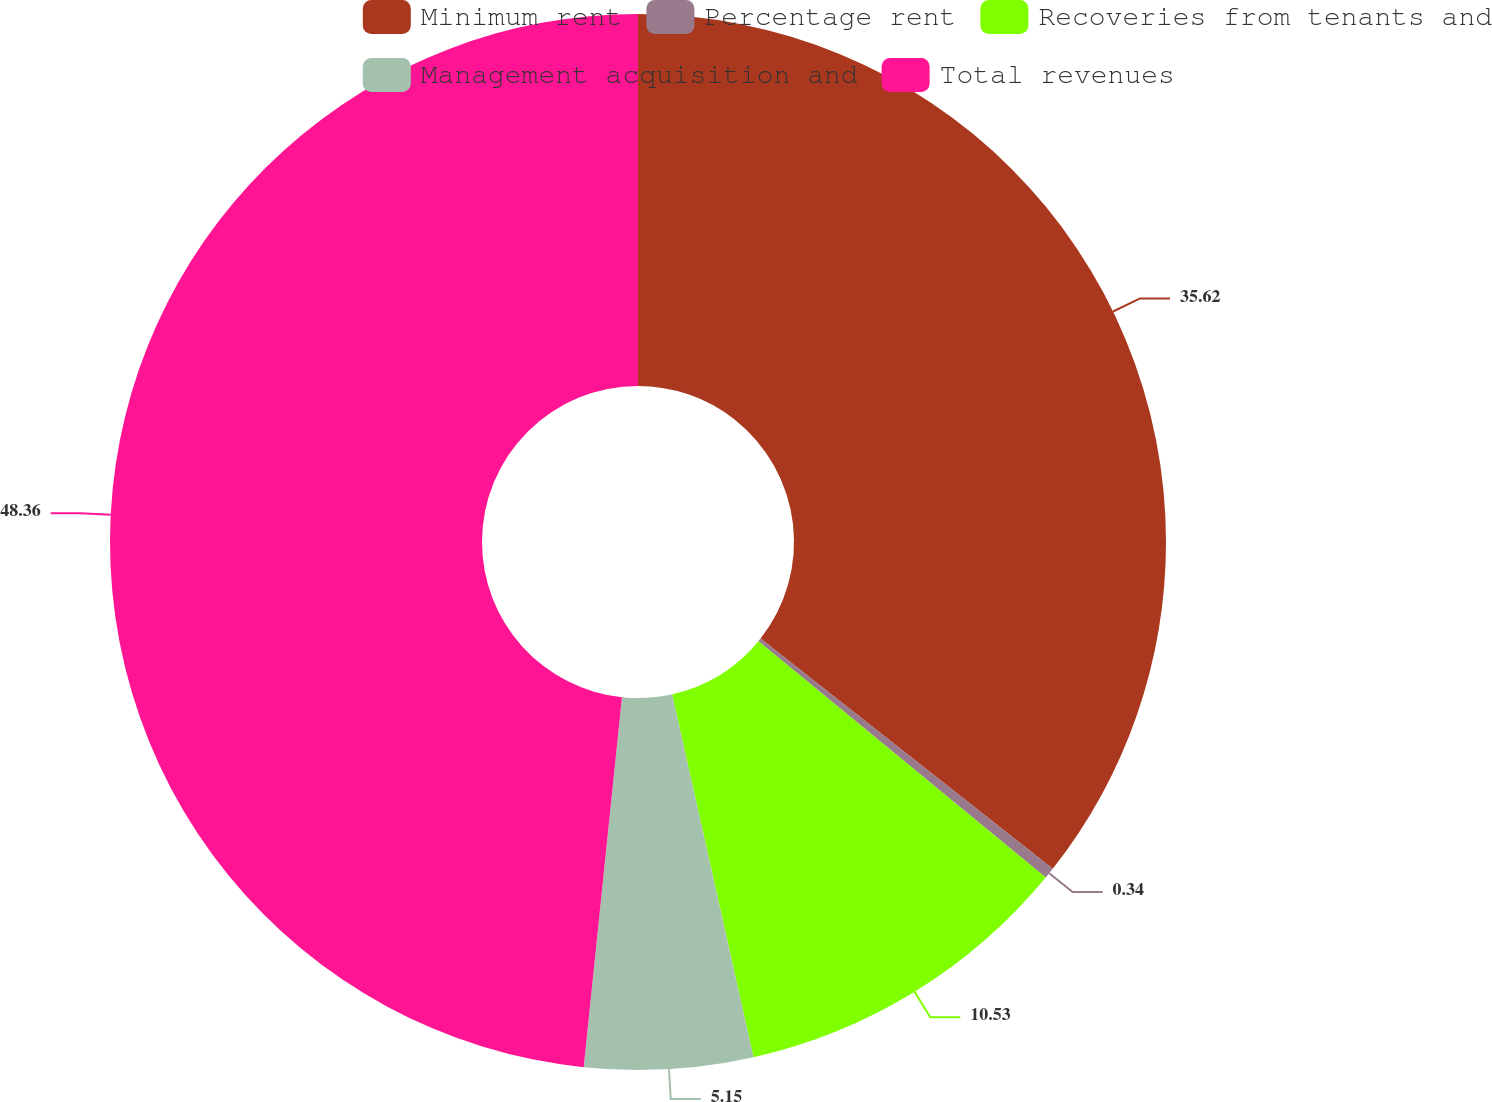Convert chart to OTSL. <chart><loc_0><loc_0><loc_500><loc_500><pie_chart><fcel>Minimum rent<fcel>Percentage rent<fcel>Recoveries from tenants and<fcel>Management acquisition and<fcel>Total revenues<nl><fcel>35.62%<fcel>0.34%<fcel>10.53%<fcel>5.15%<fcel>48.36%<nl></chart> 